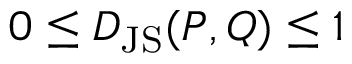Convert formula to latex. <formula><loc_0><loc_0><loc_500><loc_500>0 \leq D _ { J S } ( P , Q ) \leq 1</formula> 